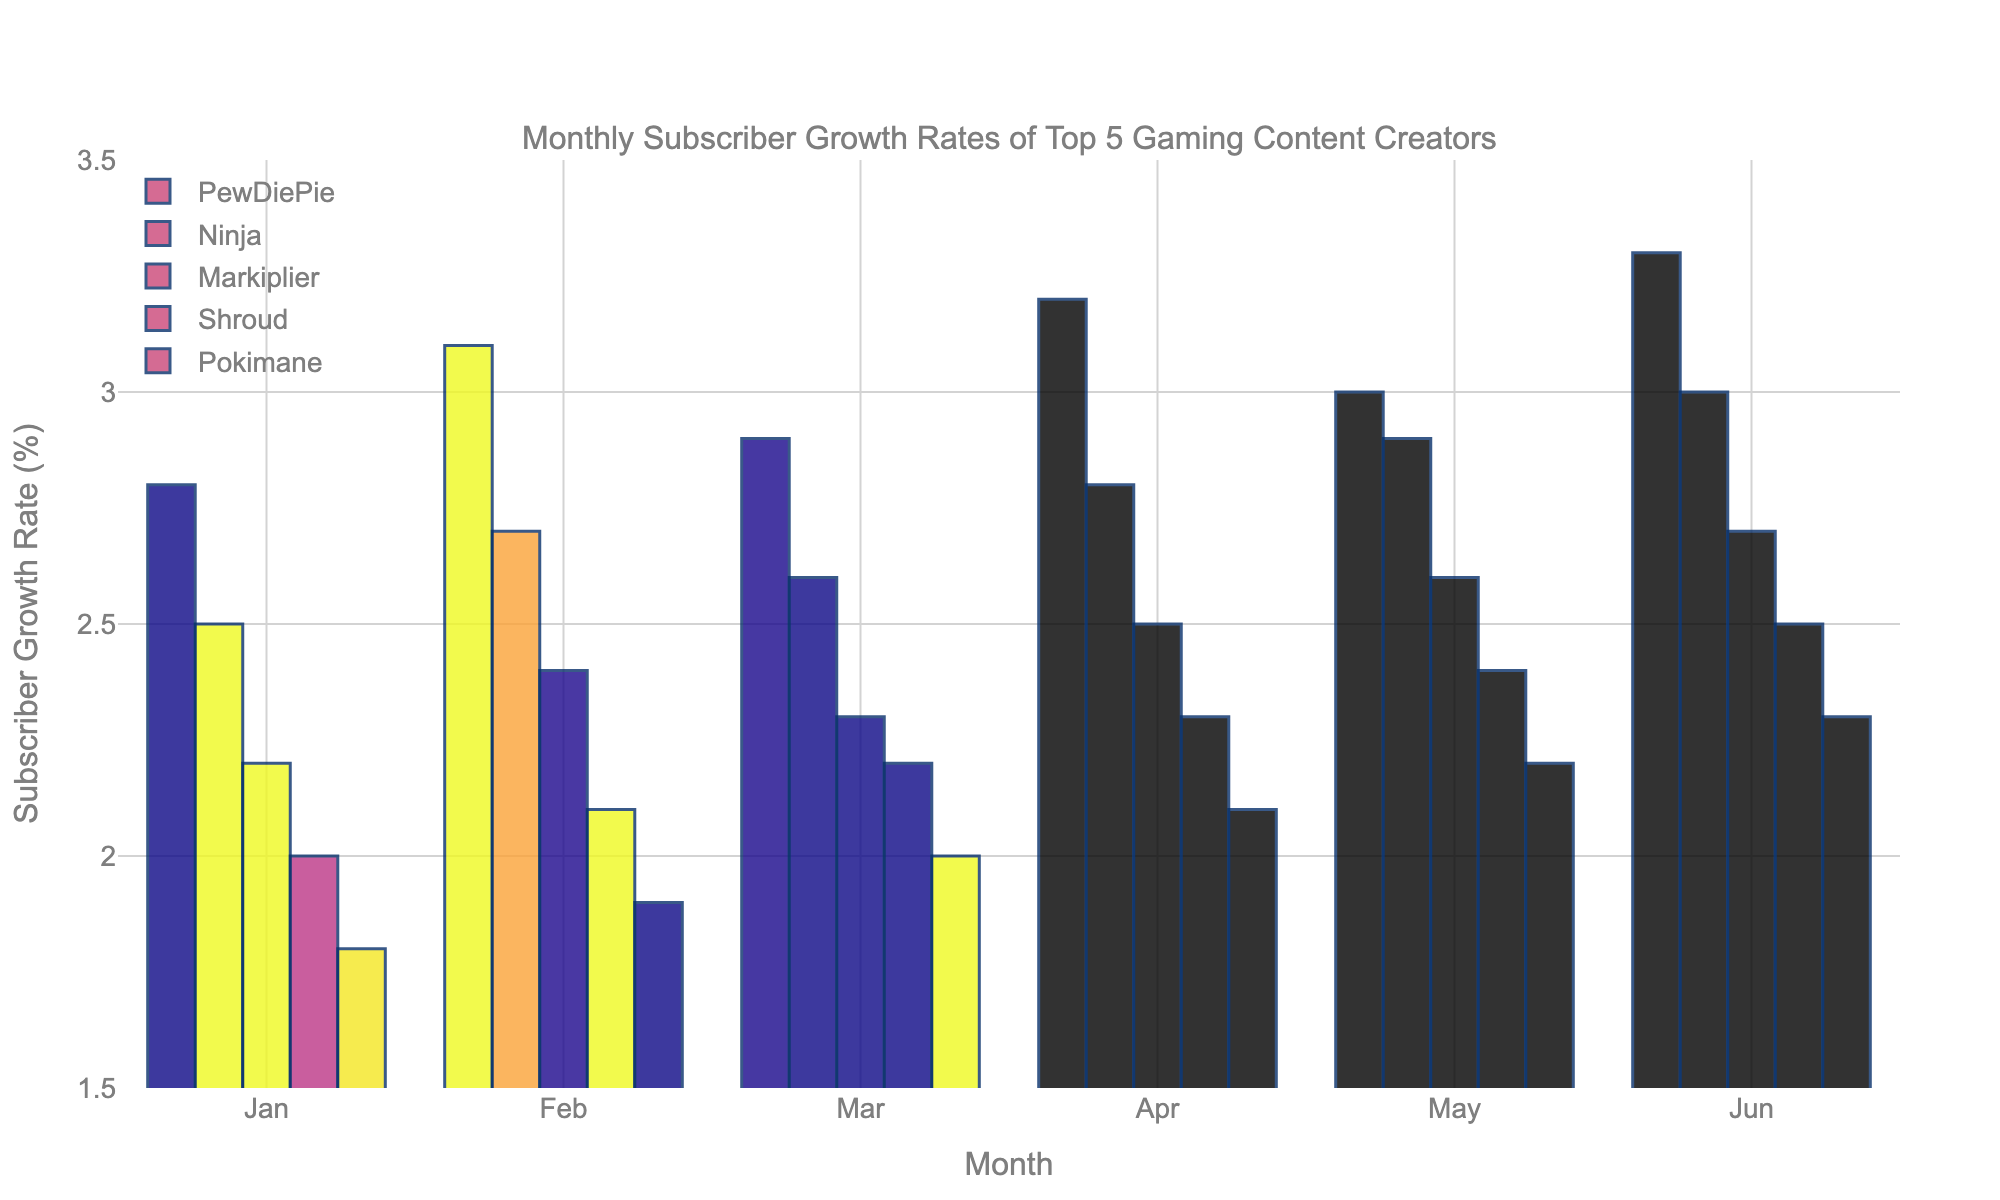Which content creator had the highest subscriber growth rate in June? By looking at the bars for June, the tallest bar represents PewDiePie, indicating he had the highest subscriber growth rate in June.
Answer: PewDiePie What is the average growth rate for Ninja over the six months? Summing up Ninja's monthly growth rates (2.5 + 2.7 + 2.6 + 2.8 + 2.9 + 3.0) gives 17.5. Dividing by 6 months, the average growth rate is approximately 2.92%.
Answer: 2.92% Which two content creators had the closest growth rates in May? By comparing the bars for May, Markiplier and Shroud have the closest heights, representing growth rates of 2.6% and 2.4% respectively.
Answer: Markiplier and Shroud In which month did Pokimane's growth rate surpass 2%? We observe the bars for Pokimane and the month where her growth rate is just above 2%. It happened in March.
Answer: March How much more was PewDiePie's growth rate in April compared to February? PewDiePie's growth rate in April was 3.2%, and in February, it was 3.1%. The difference is 3.2% - 3.1% = 0.1%.
Answer: 0.1% Which content creator showed a steady increase in their subscriber growth rate each month? By observing the trends for each content creator, Shroud shows a consistent increase each month from January to June.
Answer: Shroud What was the combined growth rate of all content creators in January? Adding the January growth rates for all creators: 2.8 + 2.5 + 2.2 + 2.0 + 1.8 = 11.3%.
Answer: 11.3% Who had the lowest growth rate in January and what was it? The shortest bar in January corresponds to Pokimane, with a growth rate of 1.8%.
Answer: Pokimane, 1.8% Which content creator had the most significant increase in growth rate from March to April? Comparing the increase for each streamer from March to April, PewDiePie increased from 2.9% to 3.2%, which is the highest increment of 0.3%.
Answer: PewDiePie 